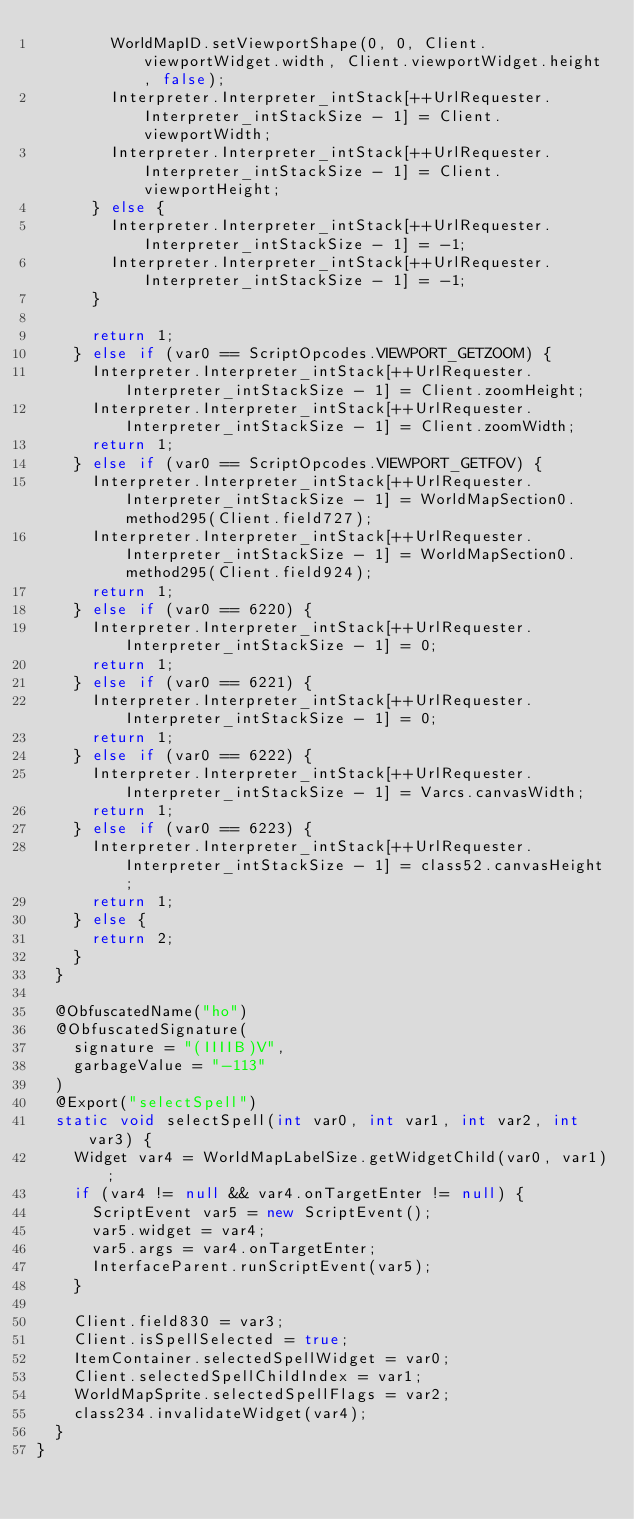Convert code to text. <code><loc_0><loc_0><loc_500><loc_500><_Java_>				WorldMapID.setViewportShape(0, 0, Client.viewportWidget.width, Client.viewportWidget.height, false);
				Interpreter.Interpreter_intStack[++UrlRequester.Interpreter_intStackSize - 1] = Client.viewportWidth;
				Interpreter.Interpreter_intStack[++UrlRequester.Interpreter_intStackSize - 1] = Client.viewportHeight;
			} else {
				Interpreter.Interpreter_intStack[++UrlRequester.Interpreter_intStackSize - 1] = -1;
				Interpreter.Interpreter_intStack[++UrlRequester.Interpreter_intStackSize - 1] = -1;
			}

			return 1;
		} else if (var0 == ScriptOpcodes.VIEWPORT_GETZOOM) {
			Interpreter.Interpreter_intStack[++UrlRequester.Interpreter_intStackSize - 1] = Client.zoomHeight;
			Interpreter.Interpreter_intStack[++UrlRequester.Interpreter_intStackSize - 1] = Client.zoomWidth;
			return 1;
		} else if (var0 == ScriptOpcodes.VIEWPORT_GETFOV) {
			Interpreter.Interpreter_intStack[++UrlRequester.Interpreter_intStackSize - 1] = WorldMapSection0.method295(Client.field727);
			Interpreter.Interpreter_intStack[++UrlRequester.Interpreter_intStackSize - 1] = WorldMapSection0.method295(Client.field924);
			return 1;
		} else if (var0 == 6220) {
			Interpreter.Interpreter_intStack[++UrlRequester.Interpreter_intStackSize - 1] = 0;
			return 1;
		} else if (var0 == 6221) {
			Interpreter.Interpreter_intStack[++UrlRequester.Interpreter_intStackSize - 1] = 0;
			return 1;
		} else if (var0 == 6222) {
			Interpreter.Interpreter_intStack[++UrlRequester.Interpreter_intStackSize - 1] = Varcs.canvasWidth;
			return 1;
		} else if (var0 == 6223) {
			Interpreter.Interpreter_intStack[++UrlRequester.Interpreter_intStackSize - 1] = class52.canvasHeight;
			return 1;
		} else {
			return 2;
		}
	}

	@ObfuscatedName("ho")
	@ObfuscatedSignature(
		signature = "(IIIIB)V",
		garbageValue = "-113"
	)
	@Export("selectSpell")
	static void selectSpell(int var0, int var1, int var2, int var3) {
		Widget var4 = WorldMapLabelSize.getWidgetChild(var0, var1);
		if (var4 != null && var4.onTargetEnter != null) {
			ScriptEvent var5 = new ScriptEvent();
			var5.widget = var4;
			var5.args = var4.onTargetEnter;
			InterfaceParent.runScriptEvent(var5);
		}

		Client.field830 = var3;
		Client.isSpellSelected = true;
		ItemContainer.selectedSpellWidget = var0;
		Client.selectedSpellChildIndex = var1;
		WorldMapSprite.selectedSpellFlags = var2;
		class234.invalidateWidget(var4);
	}
}
</code> 